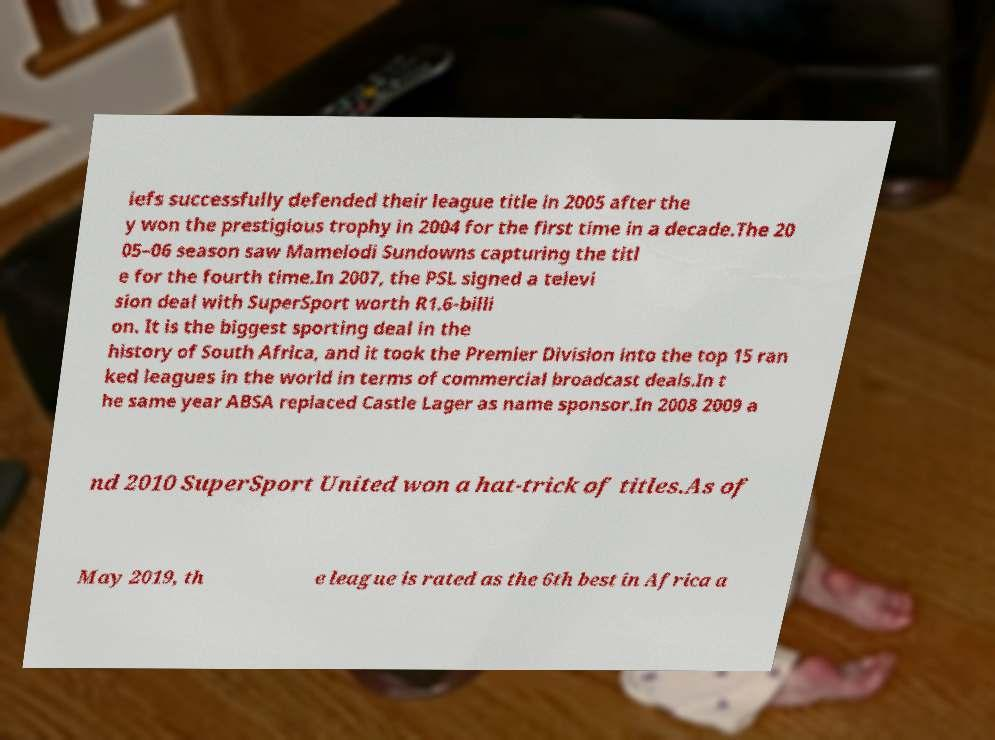Could you extract and type out the text from this image? iefs successfully defended their league title in 2005 after the y won the prestigious trophy in 2004 for the first time in a decade.The 20 05–06 season saw Mamelodi Sundowns capturing the titl e for the fourth time.In 2007, the PSL signed a televi sion deal with SuperSport worth R1.6-billi on. It is the biggest sporting deal in the history of South Africa, and it took the Premier Division into the top 15 ran ked leagues in the world in terms of commercial broadcast deals.In t he same year ABSA replaced Castle Lager as name sponsor.In 2008 2009 a nd 2010 SuperSport United won a hat-trick of titles.As of May 2019, th e league is rated as the 6th best in Africa a 